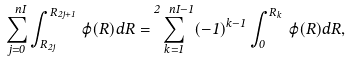Convert formula to latex. <formula><loc_0><loc_0><loc_500><loc_500>\sum _ { j = 0 } ^ { \ n I } \int _ { R _ { 2 j } } ^ { R _ { 2 j + 1 } } \, \varphi ( R ) d R = \sum _ { k = 1 } ^ { 2 \ n I - 1 } ( - 1 ) ^ { k - 1 } \int _ { 0 } ^ { R _ { k } } \, \varphi ( R ) d R ,</formula> 